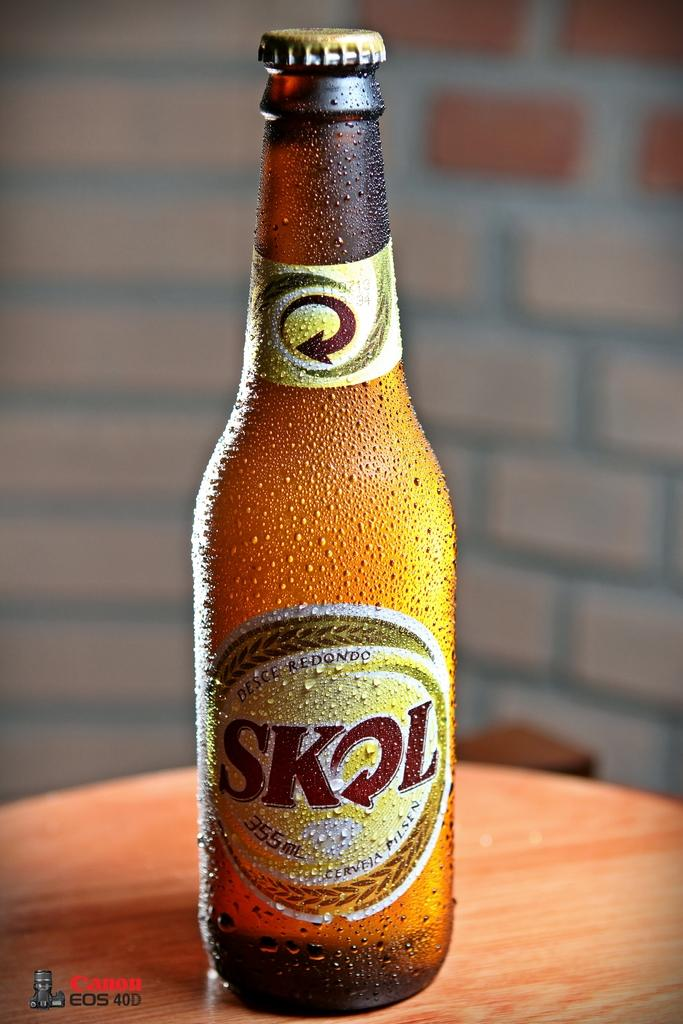<image>
Relay a brief, clear account of the picture shown. A bottle of Skol sits on small round table. 